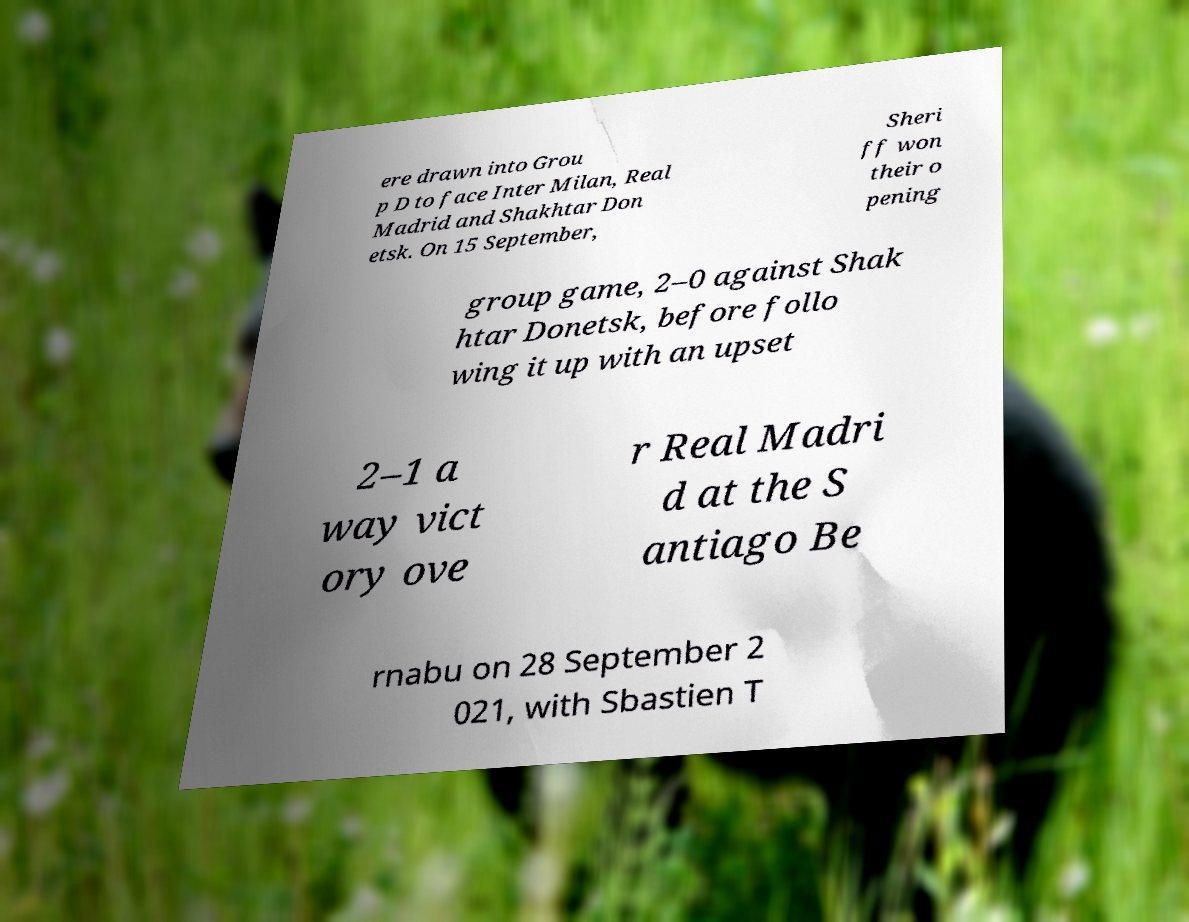Can you accurately transcribe the text from the provided image for me? ere drawn into Grou p D to face Inter Milan, Real Madrid and Shakhtar Don etsk. On 15 September, Sheri ff won their o pening group game, 2–0 against Shak htar Donetsk, before follo wing it up with an upset 2–1 a way vict ory ove r Real Madri d at the S antiago Be rnabu on 28 September 2 021, with Sbastien T 